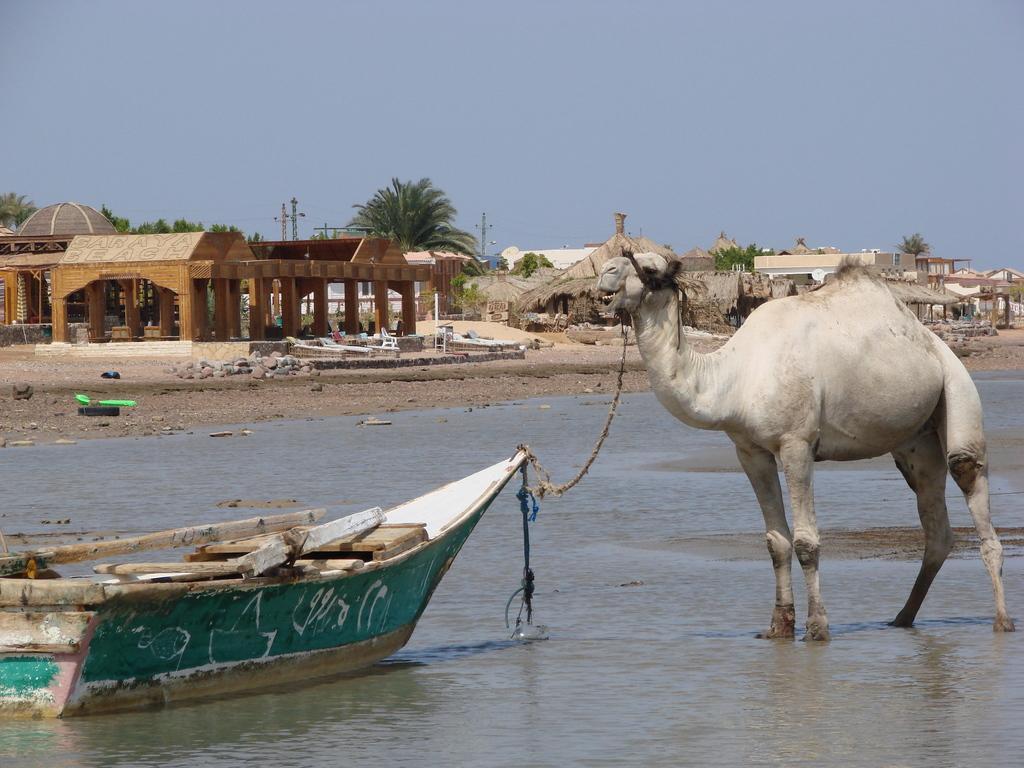Please provide a concise description of this image. There is a camel tied o n boat. This is water. In the background we can see houses, stones, trees, poles, and sky. 